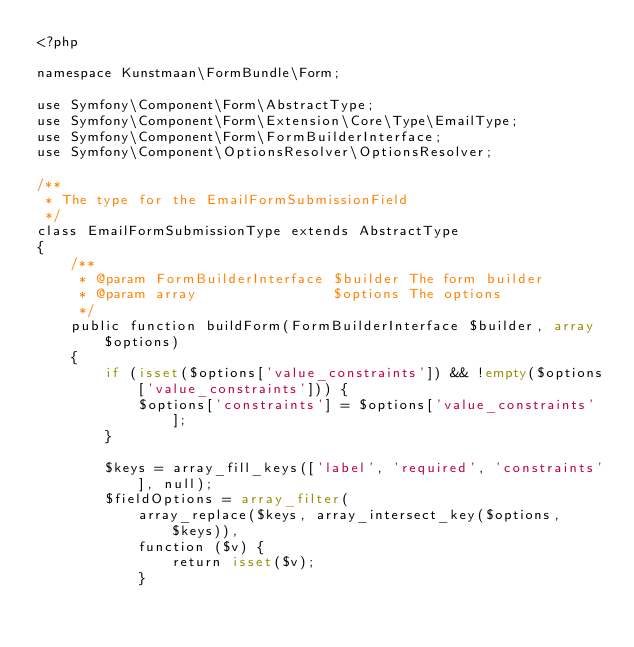<code> <loc_0><loc_0><loc_500><loc_500><_PHP_><?php

namespace Kunstmaan\FormBundle\Form;

use Symfony\Component\Form\AbstractType;
use Symfony\Component\Form\Extension\Core\Type\EmailType;
use Symfony\Component\Form\FormBuilderInterface;
use Symfony\Component\OptionsResolver\OptionsResolver;

/**
 * The type for the EmailFormSubmissionField
 */
class EmailFormSubmissionType extends AbstractType
{
    /**
     * @param FormBuilderInterface $builder The form builder
     * @param array                $options The options
     */
    public function buildForm(FormBuilderInterface $builder, array $options)
    {
        if (isset($options['value_constraints']) && !empty($options['value_constraints'])) {
            $options['constraints'] = $options['value_constraints'];
        }

        $keys = array_fill_keys(['label', 'required', 'constraints'], null);
        $fieldOptions = array_filter(
            array_replace($keys, array_intersect_key($options, $keys)),
            function ($v) {
                return isset($v);
            }</code> 